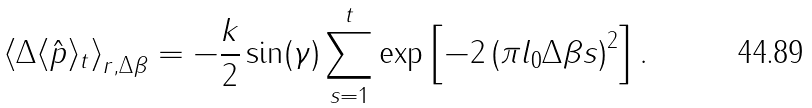<formula> <loc_0><loc_0><loc_500><loc_500>\left \langle \Delta \langle \hat { p } \rangle _ { t } \right \rangle _ { r , \Delta \beta } = - \frac { k } { 2 } \sin ( \gamma ) \sum _ { s = 1 } ^ { t } \exp \left [ - 2 \left ( \pi l _ { 0 } \Delta \beta s \right ) ^ { 2 } \right ] .</formula> 